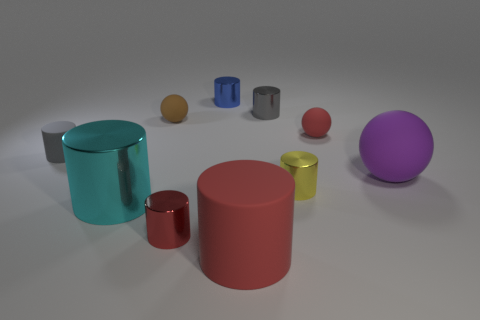Subtract 1 cylinders. How many cylinders are left? 6 Subtract all blue shiny cylinders. How many cylinders are left? 6 Subtract all cyan cylinders. How many cylinders are left? 6 Subtract all blue cylinders. Subtract all green spheres. How many cylinders are left? 6 Subtract all cylinders. How many objects are left? 3 Add 3 red shiny objects. How many red shiny objects are left? 4 Add 3 small brown metallic cylinders. How many small brown metallic cylinders exist? 3 Subtract 1 yellow cylinders. How many objects are left? 9 Subtract all big red objects. Subtract all tiny green shiny cylinders. How many objects are left? 9 